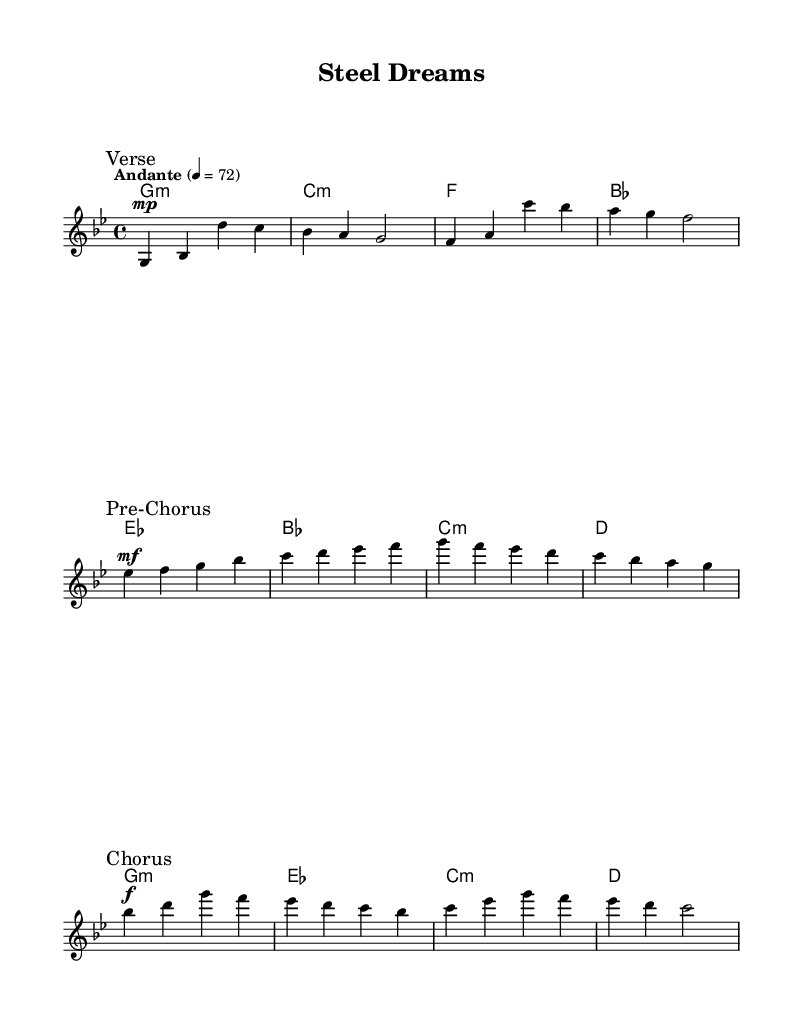What is the key signature of this music? The key signature is G minor, which is indicated at the beginning of the score. The presence of two flats supports this identification.
Answer: G minor What is the time signature of the piece? The time signature is 4/4, shown at the beginning of the score, meaning there are four beats in each measure.
Answer: 4/4 What is the tempo marking of the music? The tempo marking is "Andante," which generally indicates a moderately slow tempo. The specific metronome marking provides a more precise pace.
Answer: Andante What section follows the Verse in this composition? The section that follows the Verse is marked as the Pre-Chorus, as indicated in the score. This is evident from the section markings provided above the measures.
Answer: Pre-Chorus In what form is the chorus structured in this piece? The Chorus consists of four measures with a melodic structure supported by harmonic chords, indicating a typical repetitive form common in K-Pop ballads.
Answer: Four measures How does the dynamic change from the Verse to the Chorus? The dynamic changes from mezzo-piano (mp) in the Verse to forte (f) in the Chorus, highlighting a significant increase in intensity and emotional impact.
Answer: Increase What musical style does this piece reflect based on its structure? The piece reflects the K-Pop ballad style, characterized by its emotional content, lyrical melodies, and the common structure of verses, pre-choruses, and choruses.
Answer: K-Pop ballad 